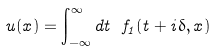<formula> <loc_0><loc_0><loc_500><loc_500>u ( x ) = \int ^ { \infty } _ { - \infty } d t \ f _ { 1 } ( t + i \delta , x )</formula> 